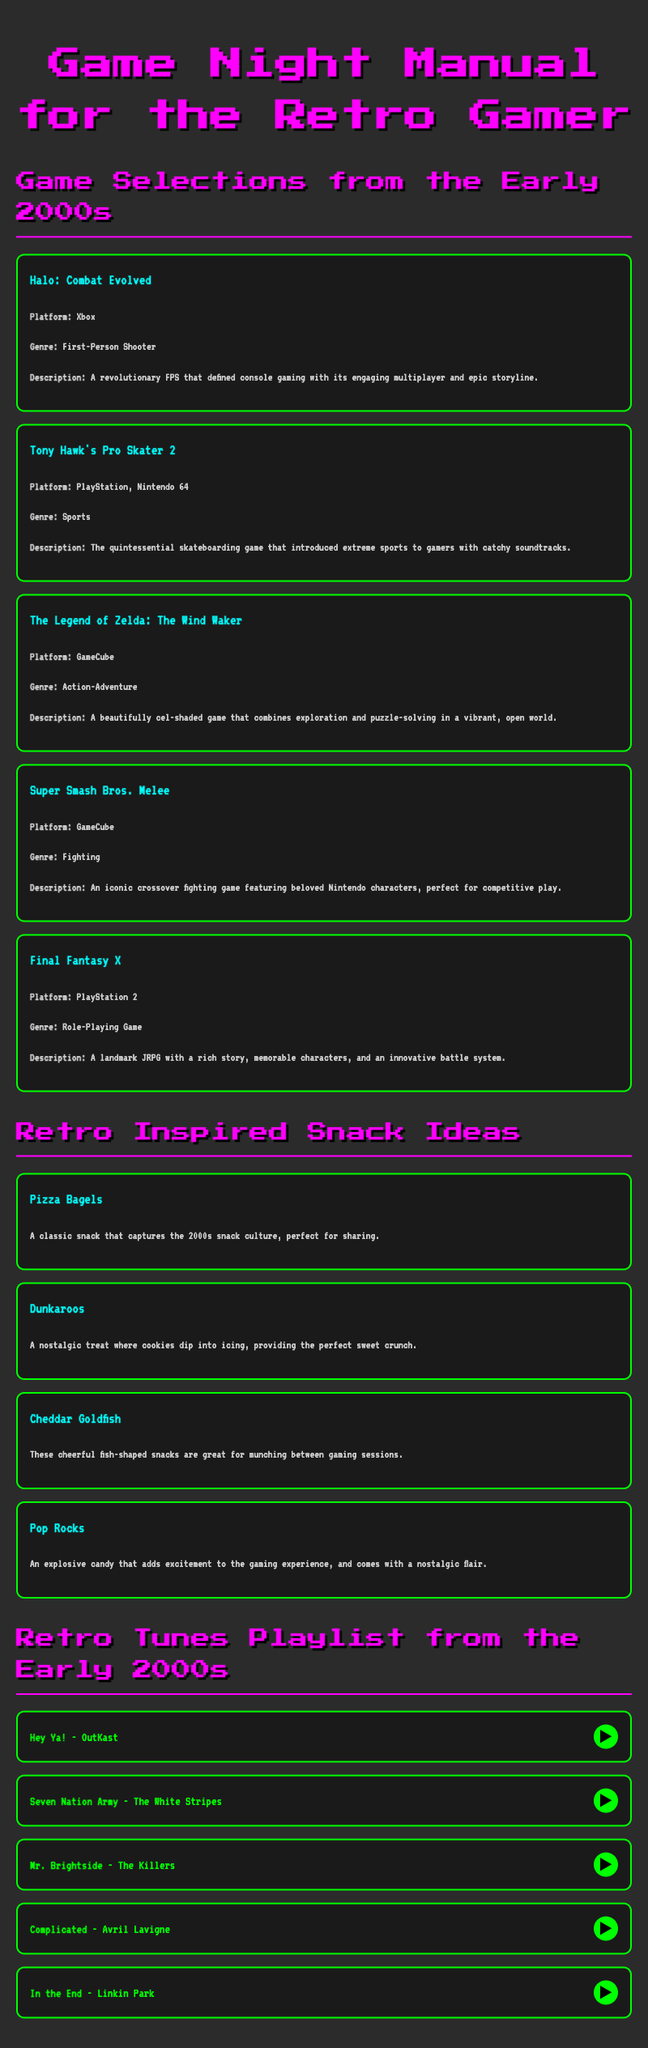What is the first game listed in the game selections? The first game listed in the game selections is "Halo: Combat Evolved".
Answer: Halo: Combat Evolved What platform is "Final Fantasy X" available on? "Final Fantasy X" is available on the PlayStation 2 platform.
Answer: PlayStation 2 How many retro snack ideas are provided? There are four retro snack ideas provided in the document.
Answer: 4 What type of game is "Tony Hawk's Pro Skater 2"? "Tony Hawk's Pro Skater 2" is categorized as a sports game.
Answer: Sports Who performed "Hey Ya!"? "Hey Ya!" is performed by OutKast.
Answer: OutKast What genre does "The Legend of Zelda: The Wind Waker" belong to? "The Legend of Zelda: The Wind Waker" belongs to the action-adventure genre.
Answer: Action-Adventure Which snack is described as an explosive candy? The snack described as an explosive candy is "Pop Rocks".
Answer: Pop Rocks What is the last song listed in the retro tunes playlist? The last song listed in the retro tunes playlist is "In the End" by Linkin Park.
Answer: In the End - Linkin Park 